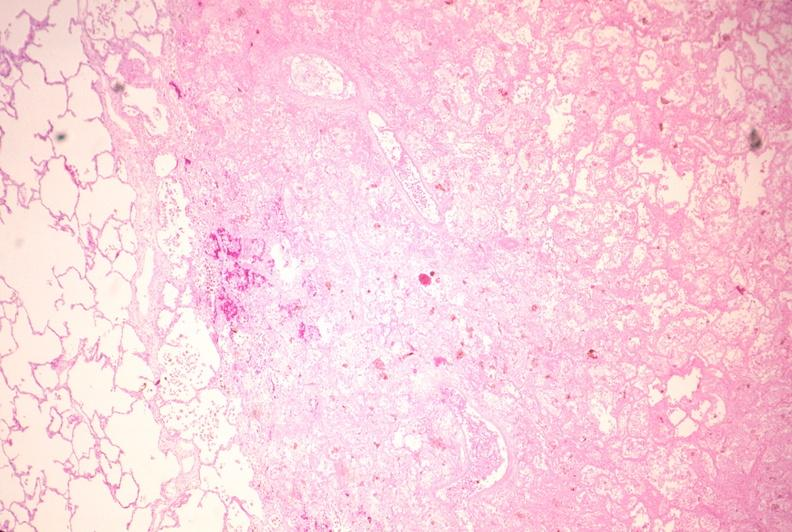s bilateral cleft palate present?
Answer the question using a single word or phrase. No 